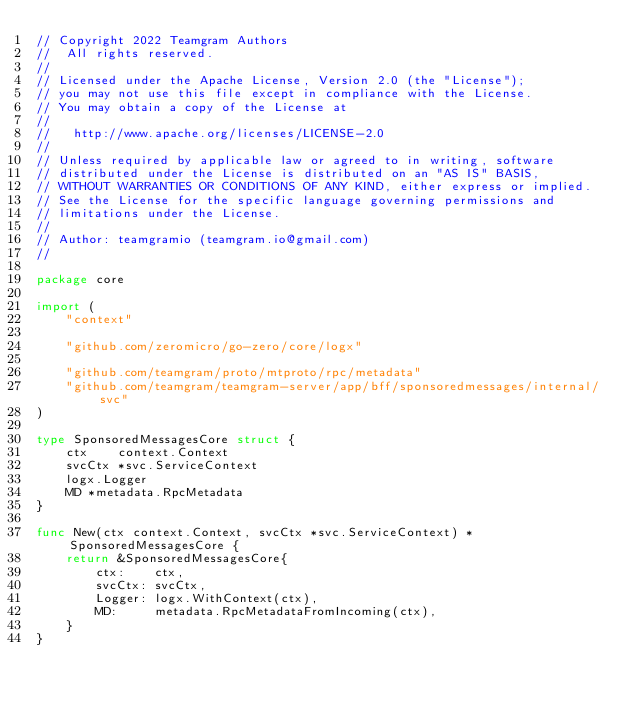<code> <loc_0><loc_0><loc_500><loc_500><_Go_>// Copyright 2022 Teamgram Authors
//  All rights reserved.
//
// Licensed under the Apache License, Version 2.0 (the "License");
// you may not use this file except in compliance with the License.
// You may obtain a copy of the License at
//
//   http://www.apache.org/licenses/LICENSE-2.0
//
// Unless required by applicable law or agreed to in writing, software
// distributed under the License is distributed on an "AS IS" BASIS,
// WITHOUT WARRANTIES OR CONDITIONS OF ANY KIND, either express or implied.
// See the License for the specific language governing permissions and
// limitations under the License.
//
// Author: teamgramio (teamgram.io@gmail.com)
//

package core

import (
	"context"

	"github.com/zeromicro/go-zero/core/logx"

	"github.com/teamgram/proto/mtproto/rpc/metadata"
	"github.com/teamgram/teamgram-server/app/bff/sponsoredmessages/internal/svc"
)

type SponsoredMessagesCore struct {
	ctx    context.Context
	svcCtx *svc.ServiceContext
	logx.Logger
	MD *metadata.RpcMetadata
}

func New(ctx context.Context, svcCtx *svc.ServiceContext) *SponsoredMessagesCore {
	return &SponsoredMessagesCore{
		ctx:    ctx,
		svcCtx: svcCtx,
		Logger: logx.WithContext(ctx),
		MD:     metadata.RpcMetadataFromIncoming(ctx),
	}
}
</code> 